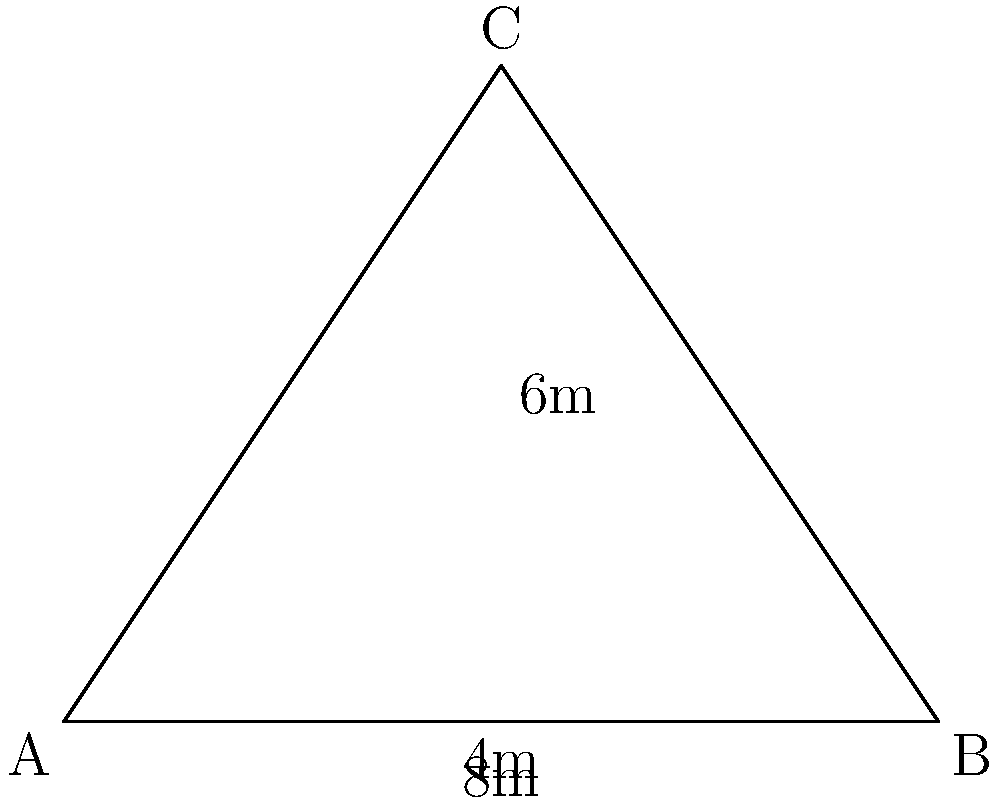For the new meditation room, you're planning a triangular roof. The base of the roof is 8 meters wide, and the height from the base to the peak is 6 meters. What is the total area of the roof in square meters? To find the area of the triangular roof, we can use the formula for the area of a triangle:

$$A = \frac{1}{2} \times base \times height$$

Given:
- Base (width) = 8 meters
- Height = 6 meters

Substituting these values into the formula:

$$A = \frac{1}{2} \times 8 \times 6$$

$$A = 4 \times 6$$

$$A = 24$$

Therefore, the area of the triangular roof is 24 square meters.
Answer: 24 m² 